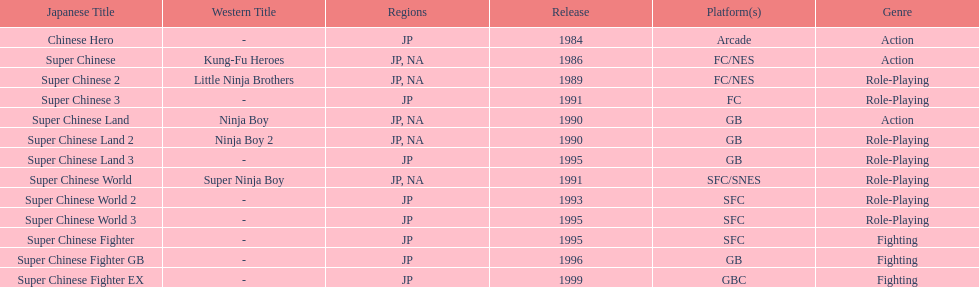When was the last super chinese game released? 1999. 